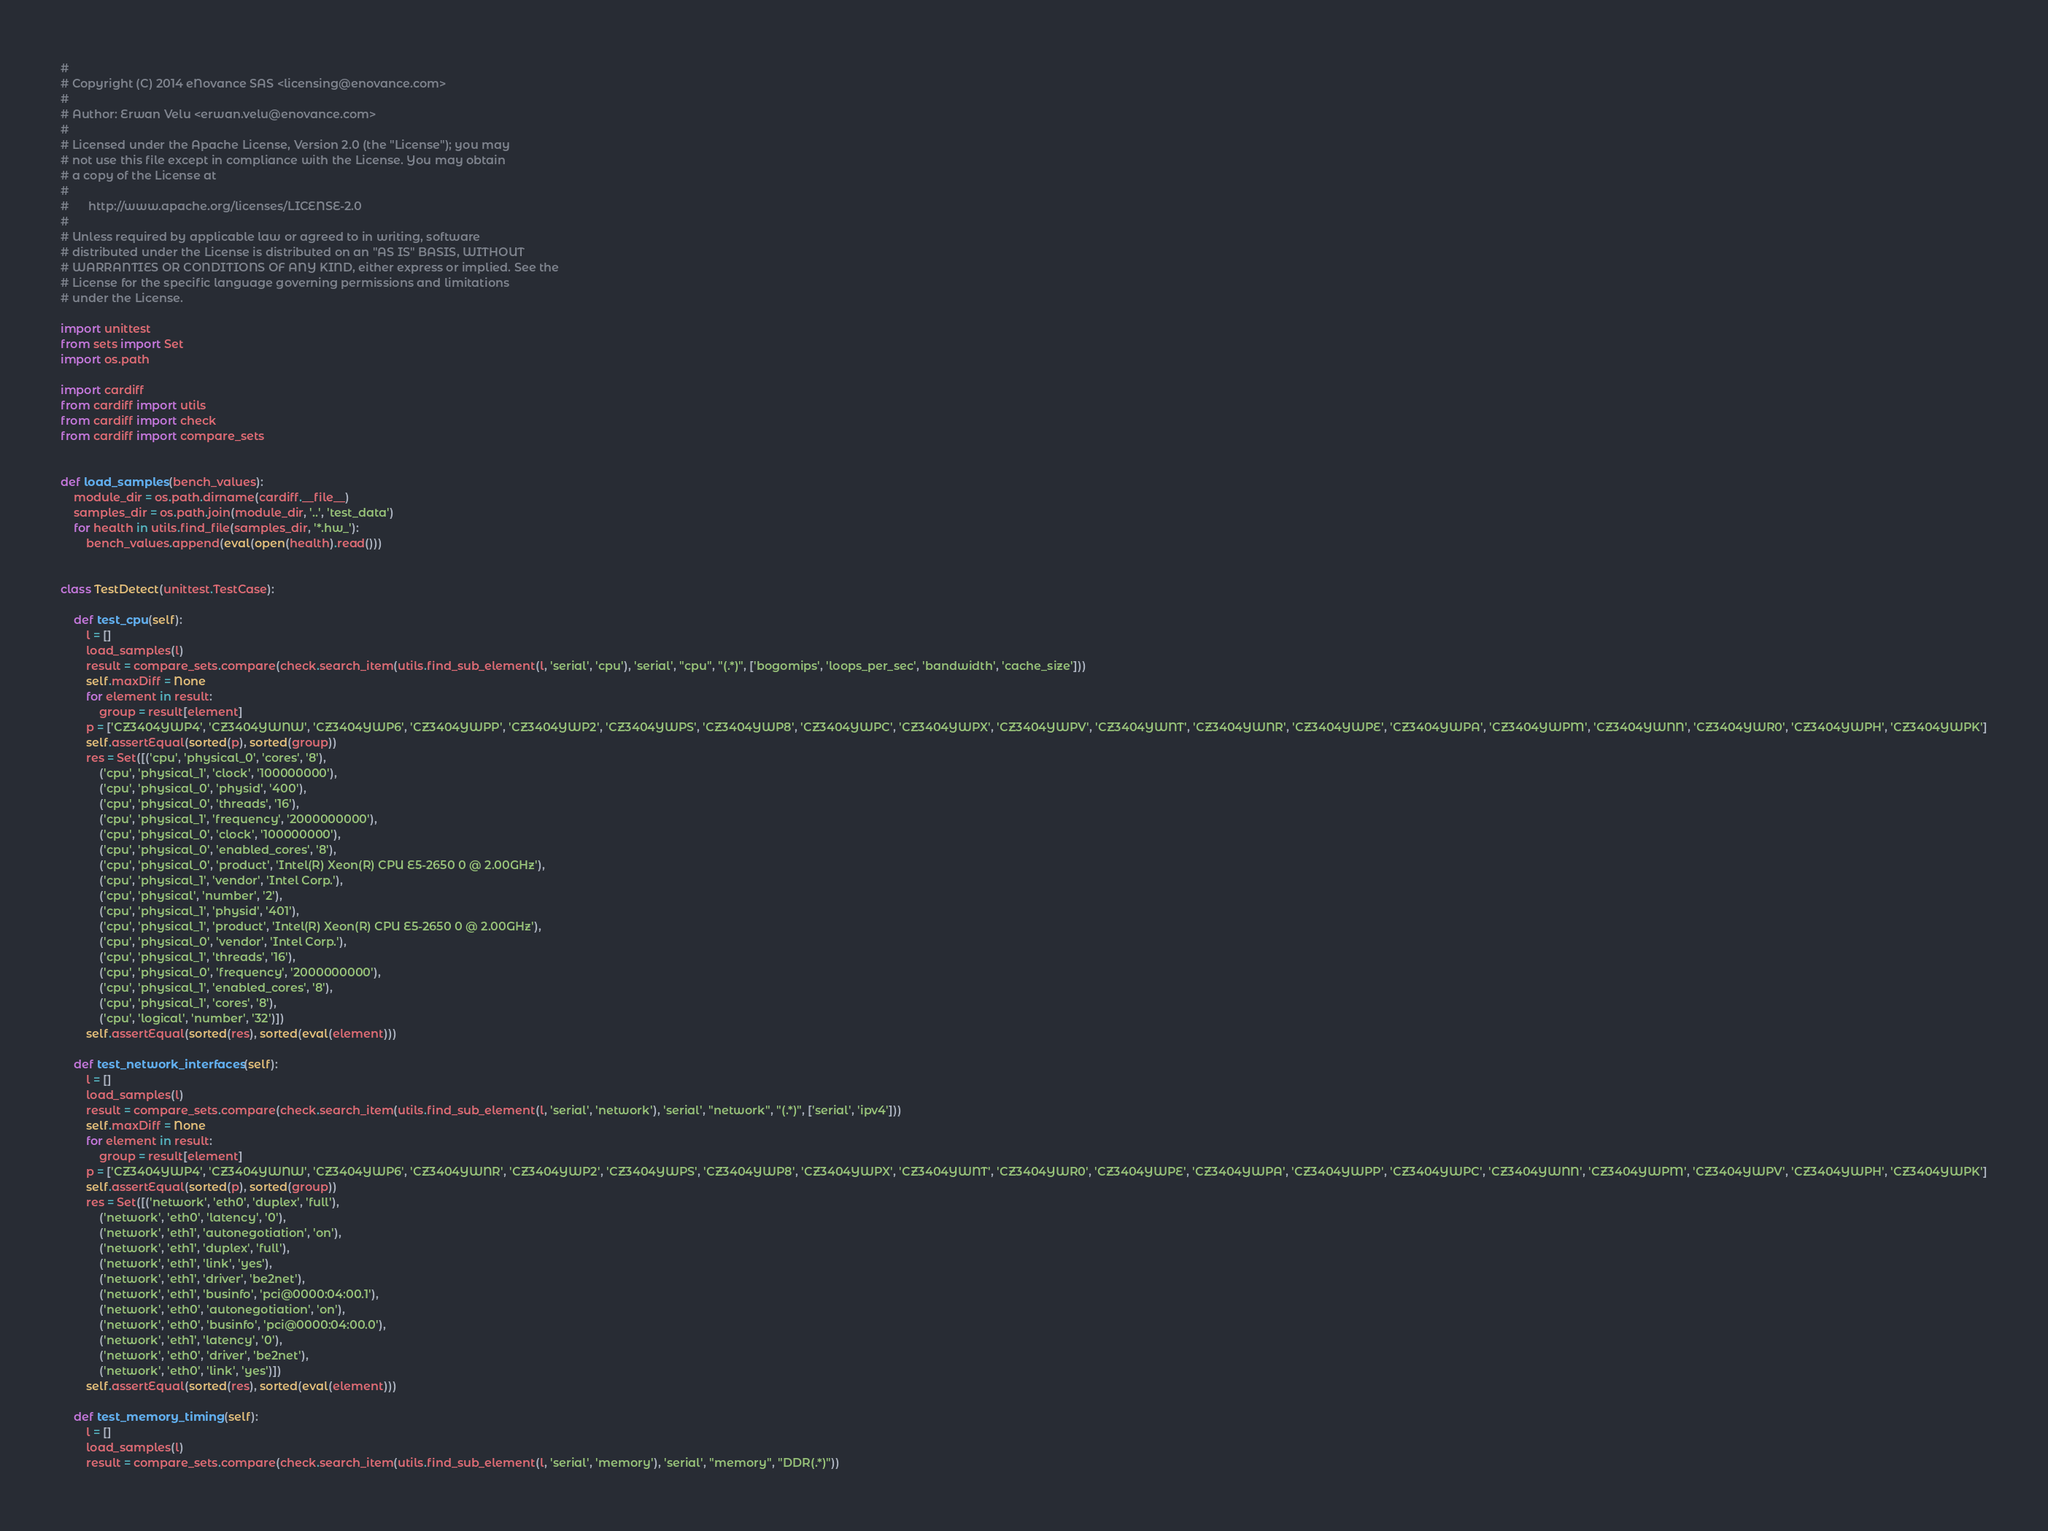<code> <loc_0><loc_0><loc_500><loc_500><_Python_>#
# Copyright (C) 2014 eNovance SAS <licensing@enovance.com>
#
# Author: Erwan Velu <erwan.velu@enovance.com>
#
# Licensed under the Apache License, Version 2.0 (the "License"); you may
# not use this file except in compliance with the License. You may obtain
# a copy of the License at
#
#      http://www.apache.org/licenses/LICENSE-2.0
#
# Unless required by applicable law or agreed to in writing, software
# distributed under the License is distributed on an "AS IS" BASIS, WITHOUT
# WARRANTIES OR CONDITIONS OF ANY KIND, either express or implied. See the
# License for the specific language governing permissions and limitations
# under the License.

import unittest
from sets import Set
import os.path

import cardiff
from cardiff import utils
from cardiff import check
from cardiff import compare_sets


def load_samples(bench_values):
    module_dir = os.path.dirname(cardiff.__file__)
    samples_dir = os.path.join(module_dir, '..', 'test_data')
    for health in utils.find_file(samples_dir, '*.hw_'):
        bench_values.append(eval(open(health).read()))


class TestDetect(unittest.TestCase):

    def test_cpu(self):
        l = []
        load_samples(l)
        result = compare_sets.compare(check.search_item(utils.find_sub_element(l, 'serial', 'cpu'), 'serial', "cpu", "(.*)", ['bogomips', 'loops_per_sec', 'bandwidth', 'cache_size']))
        self.maxDiff = None
        for element in result:
            group = result[element]
        p = ['CZ3404YWP4', 'CZ3404YWNW', 'CZ3404YWP6', 'CZ3404YWPP', 'CZ3404YWP2', 'CZ3404YWPS', 'CZ3404YWP8', 'CZ3404YWPC', 'CZ3404YWPX', 'CZ3404YWPV', 'CZ3404YWNT', 'CZ3404YWNR', 'CZ3404YWPE', 'CZ3404YWPA', 'CZ3404YWPM', 'CZ3404YWNN', 'CZ3404YWR0', 'CZ3404YWPH', 'CZ3404YWPK']
        self.assertEqual(sorted(p), sorted(group))
        res = Set([('cpu', 'physical_0', 'cores', '8'),
            ('cpu', 'physical_1', 'clock', '100000000'),
            ('cpu', 'physical_0', 'physid', '400'),
            ('cpu', 'physical_0', 'threads', '16'),
            ('cpu', 'physical_1', 'frequency', '2000000000'),
            ('cpu', 'physical_0', 'clock', '100000000'),
            ('cpu', 'physical_0', 'enabled_cores', '8'),
            ('cpu', 'physical_0', 'product', 'Intel(R) Xeon(R) CPU E5-2650 0 @ 2.00GHz'),
            ('cpu', 'physical_1', 'vendor', 'Intel Corp.'),
            ('cpu', 'physical', 'number', '2'),
            ('cpu', 'physical_1', 'physid', '401'),
            ('cpu', 'physical_1', 'product', 'Intel(R) Xeon(R) CPU E5-2650 0 @ 2.00GHz'),
            ('cpu', 'physical_0', 'vendor', 'Intel Corp.'),
            ('cpu', 'physical_1', 'threads', '16'),
            ('cpu', 'physical_0', 'frequency', '2000000000'),
            ('cpu', 'physical_1', 'enabled_cores', '8'),
            ('cpu', 'physical_1', 'cores', '8'),
            ('cpu', 'logical', 'number', '32')])
        self.assertEqual(sorted(res), sorted(eval(element)))

    def test_network_interfaces(self):
        l = []
        load_samples(l)
        result = compare_sets.compare(check.search_item(utils.find_sub_element(l, 'serial', 'network'), 'serial', "network", "(.*)", ['serial', 'ipv4']))
        self.maxDiff = None
        for element in result:
            group = result[element]
        p = ['CZ3404YWP4', 'CZ3404YWNW', 'CZ3404YWP6', 'CZ3404YWNR', 'CZ3404YWP2', 'CZ3404YWPS', 'CZ3404YWP8', 'CZ3404YWPX', 'CZ3404YWNT', 'CZ3404YWR0', 'CZ3404YWPE', 'CZ3404YWPA', 'CZ3404YWPP', 'CZ3404YWPC', 'CZ3404YWNN', 'CZ3404YWPM', 'CZ3404YWPV', 'CZ3404YWPH', 'CZ3404YWPK']
        self.assertEqual(sorted(p), sorted(group))
        res = Set([('network', 'eth0', 'duplex', 'full'),
            ('network', 'eth0', 'latency', '0'),
            ('network', 'eth1', 'autonegotiation', 'on'),
            ('network', 'eth1', 'duplex', 'full'),
            ('network', 'eth1', 'link', 'yes'),
            ('network', 'eth1', 'driver', 'be2net'),
            ('network', 'eth1', 'businfo', 'pci@0000:04:00.1'),
            ('network', 'eth0', 'autonegotiation', 'on'),
            ('network', 'eth0', 'businfo', 'pci@0000:04:00.0'),
            ('network', 'eth1', 'latency', '0'),
            ('network', 'eth0', 'driver', 'be2net'),
            ('network', 'eth0', 'link', 'yes')])
        self.assertEqual(sorted(res), sorted(eval(element)))

    def test_memory_timing(self):
        l = []
        load_samples(l)
        result = compare_sets.compare(check.search_item(utils.find_sub_element(l, 'serial', 'memory'), 'serial', "memory", "DDR(.*)"))</code> 